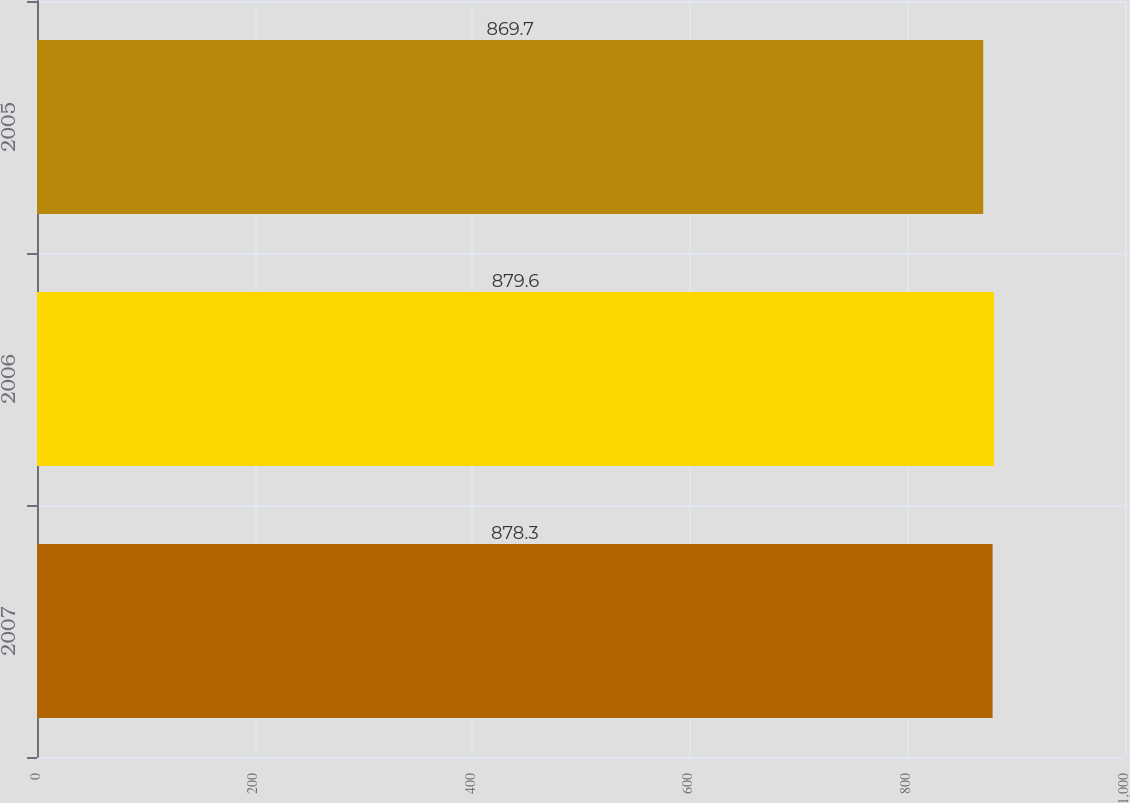<chart> <loc_0><loc_0><loc_500><loc_500><bar_chart><fcel>2007<fcel>2006<fcel>2005<nl><fcel>878.3<fcel>879.6<fcel>869.7<nl></chart> 